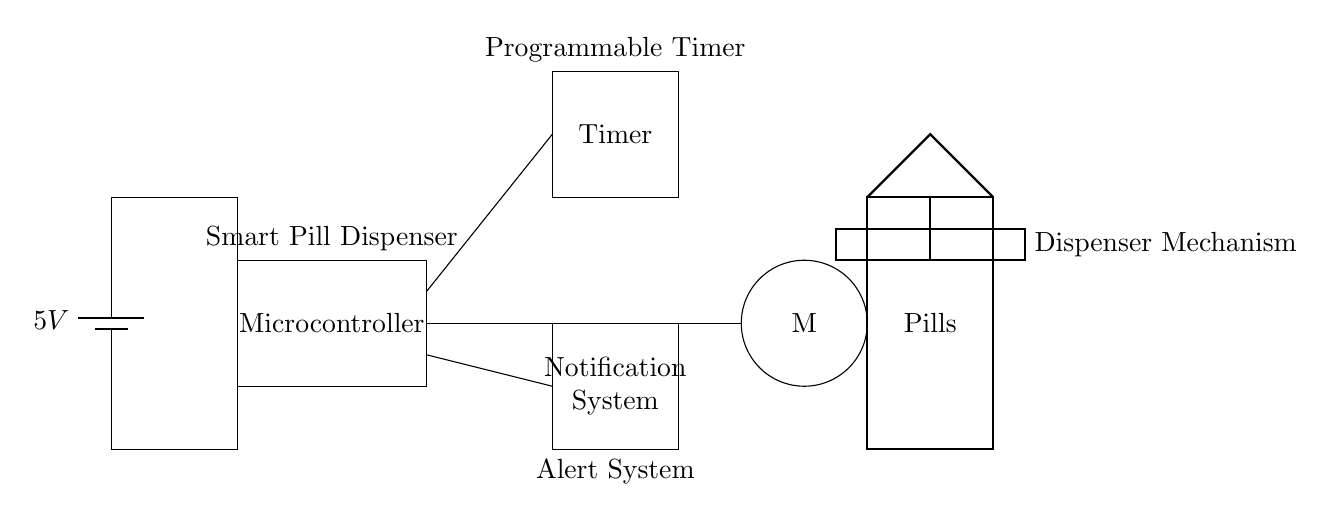What is the voltage of this circuit? The voltage is specified as 5V in the circuit. It is indicated at the battery component, which serves as the power supply for the entire circuit.
Answer: 5V What are the main components in this circuit? The main components include a microcontroller, a timer, a notification system, a motor for the pill dispenser, and a pill container. These elements are identifiable from the labeled rectangles and circle in the diagram.
Answer: Microcontroller, Timer, Notification system, Motor, Pill container Which component is responsible for alert notifications? The notification system is responsible for sending alerts. It is depicted as a rectangle at the bottom of the diagram, clearly labeled to indicate its function within the smart pill dispenser.
Answer: Notification System What is the purpose of the timer in this circuit? The timer is used to schedule when the pills should be dispensed. Its position in the circuit, connected to the microcontroller, suggests it regulates the timing aspect of the pill dispensing process.
Answer: Schedule dispensing How does the motor interact with the dispenser mechanism? The motor is directly linked to the dispenser mechanism, which allows it to physically dispense the pills when activated. The circle labeled "M" indicates the motor's role in the system, which is to engage the dispensation mechanism.
Answer: Physically dispenses pills How does the power supply connect to the microcontroller? The power supply connects to the microcontroller through a direct line from the battery to the microcontroller's input, as shown in the diagram with an upward connection. This ensures that the microcontroller receives the necessary power to function.
Answer: Direct connection 